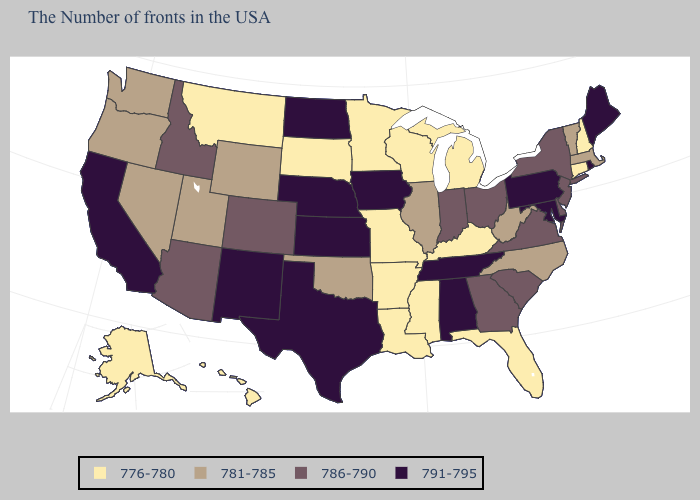Does Virginia have a lower value than Colorado?
Keep it brief. No. What is the value of Pennsylvania?
Be succinct. 791-795. Does the first symbol in the legend represent the smallest category?
Answer briefly. Yes. Does Colorado have the highest value in the West?
Short answer required. No. Name the states that have a value in the range 786-790?
Short answer required. New York, New Jersey, Delaware, Virginia, South Carolina, Ohio, Georgia, Indiana, Colorado, Arizona, Idaho. What is the value of Nebraska?
Give a very brief answer. 791-795. Does the map have missing data?
Quick response, please. No. Among the states that border Oregon , does Washington have the lowest value?
Answer briefly. Yes. What is the lowest value in states that border Mississippi?
Write a very short answer. 776-780. Which states have the lowest value in the USA?
Write a very short answer. New Hampshire, Connecticut, Florida, Michigan, Kentucky, Wisconsin, Mississippi, Louisiana, Missouri, Arkansas, Minnesota, South Dakota, Montana, Alaska, Hawaii. Name the states that have a value in the range 791-795?
Answer briefly. Maine, Rhode Island, Maryland, Pennsylvania, Alabama, Tennessee, Iowa, Kansas, Nebraska, Texas, North Dakota, New Mexico, California. Among the states that border Illinois , which have the lowest value?
Concise answer only. Kentucky, Wisconsin, Missouri. What is the highest value in the Northeast ?
Quick response, please. 791-795. Name the states that have a value in the range 776-780?
Keep it brief. New Hampshire, Connecticut, Florida, Michigan, Kentucky, Wisconsin, Mississippi, Louisiana, Missouri, Arkansas, Minnesota, South Dakota, Montana, Alaska, Hawaii. Does Mississippi have the highest value in the USA?
Write a very short answer. No. 